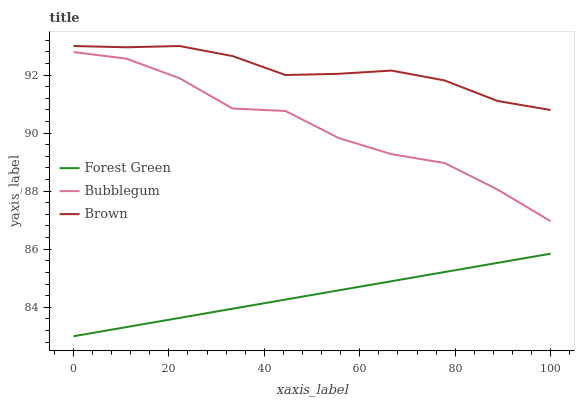Does Forest Green have the minimum area under the curve?
Answer yes or no. Yes. Does Brown have the maximum area under the curve?
Answer yes or no. Yes. Does Bubblegum have the minimum area under the curve?
Answer yes or no. No. Does Bubblegum have the maximum area under the curve?
Answer yes or no. No. Is Forest Green the smoothest?
Answer yes or no. Yes. Is Bubblegum the roughest?
Answer yes or no. Yes. Is Bubblegum the smoothest?
Answer yes or no. No. Is Forest Green the roughest?
Answer yes or no. No. Does Forest Green have the lowest value?
Answer yes or no. Yes. Does Bubblegum have the lowest value?
Answer yes or no. No. Does Brown have the highest value?
Answer yes or no. Yes. Does Bubblegum have the highest value?
Answer yes or no. No. Is Forest Green less than Bubblegum?
Answer yes or no. Yes. Is Brown greater than Forest Green?
Answer yes or no. Yes. Does Forest Green intersect Bubblegum?
Answer yes or no. No. 